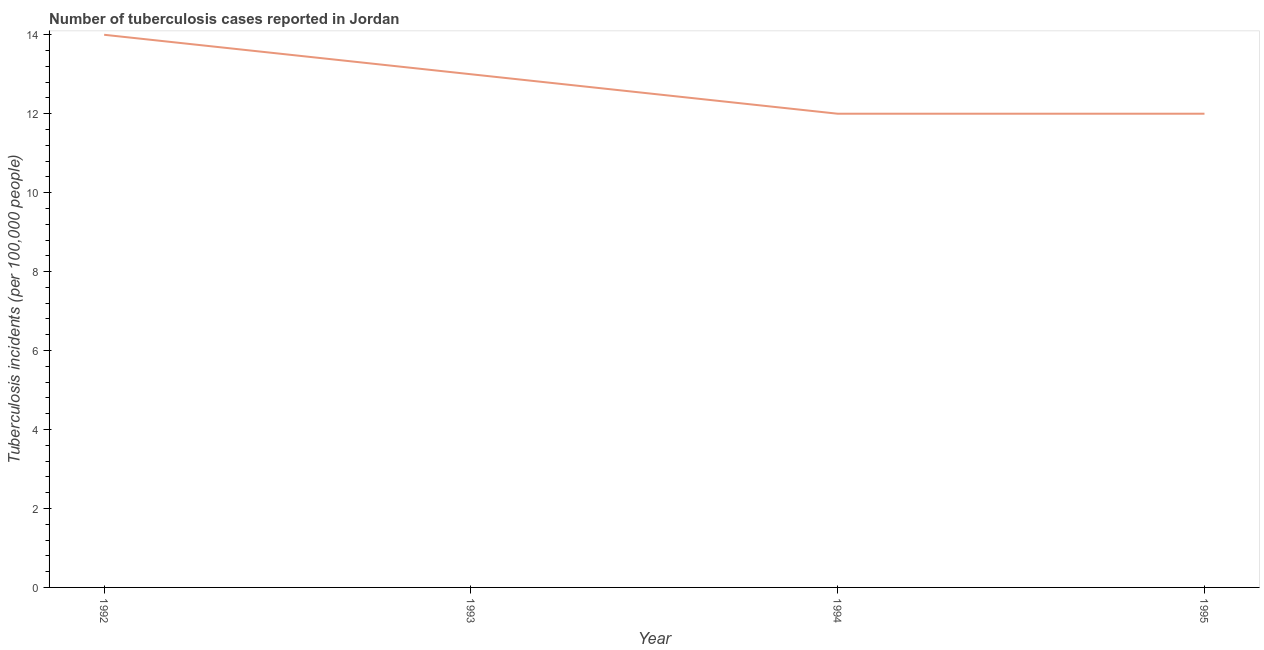What is the difference between the number of tuberculosis incidents in 1992 and 1995?
Provide a short and direct response. 2. What is the average number of tuberculosis incidents per year?
Provide a short and direct response. 12.75. Do a majority of the years between 1995 and 1993 (inclusive) have number of tuberculosis incidents greater than 2 ?
Give a very brief answer. No. What is the ratio of the number of tuberculosis incidents in 1993 to that in 1995?
Provide a short and direct response. 1.08. Is the difference between the number of tuberculosis incidents in 1992 and 1994 greater than the difference between any two years?
Your response must be concise. Yes. What is the difference between the highest and the second highest number of tuberculosis incidents?
Offer a terse response. 1. What is the difference between the highest and the lowest number of tuberculosis incidents?
Make the answer very short. 2. In how many years, is the number of tuberculosis incidents greater than the average number of tuberculosis incidents taken over all years?
Provide a succinct answer. 2. What is the difference between two consecutive major ticks on the Y-axis?
Your answer should be very brief. 2. What is the title of the graph?
Offer a very short reply. Number of tuberculosis cases reported in Jordan. What is the label or title of the X-axis?
Keep it short and to the point. Year. What is the label or title of the Y-axis?
Keep it short and to the point. Tuberculosis incidents (per 100,0 people). What is the Tuberculosis incidents (per 100,000 people) of 1992?
Make the answer very short. 14. What is the Tuberculosis incidents (per 100,000 people) in 1993?
Your answer should be very brief. 13. What is the Tuberculosis incidents (per 100,000 people) of 1994?
Offer a terse response. 12. What is the difference between the Tuberculosis incidents (per 100,000 people) in 1992 and 1995?
Your response must be concise. 2. What is the difference between the Tuberculosis incidents (per 100,000 people) in 1993 and 1994?
Offer a terse response. 1. What is the difference between the Tuberculosis incidents (per 100,000 people) in 1993 and 1995?
Your response must be concise. 1. What is the ratio of the Tuberculosis incidents (per 100,000 people) in 1992 to that in 1993?
Make the answer very short. 1.08. What is the ratio of the Tuberculosis incidents (per 100,000 people) in 1992 to that in 1994?
Your answer should be very brief. 1.17. What is the ratio of the Tuberculosis incidents (per 100,000 people) in 1992 to that in 1995?
Offer a terse response. 1.17. What is the ratio of the Tuberculosis incidents (per 100,000 people) in 1993 to that in 1994?
Make the answer very short. 1.08. What is the ratio of the Tuberculosis incidents (per 100,000 people) in 1993 to that in 1995?
Ensure brevity in your answer.  1.08. 